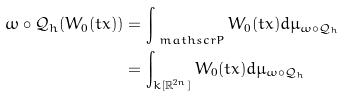Convert formula to latex. <formula><loc_0><loc_0><loc_500><loc_500>\omega \circ \mathcal { Q } _ { h } ( W _ { 0 } ( t x ) ) & = \int _ { \ m a t h s c r { P } } W _ { 0 } ( t x ) d \mu _ { \omega \circ \mathcal { Q } _ { h } } \\ & = \int _ { k [ \mathbb { R } ^ { 2 n } ] } W _ { 0 } ( t x ) d \mu _ { \omega \circ \mathcal { Q } _ { h } }</formula> 